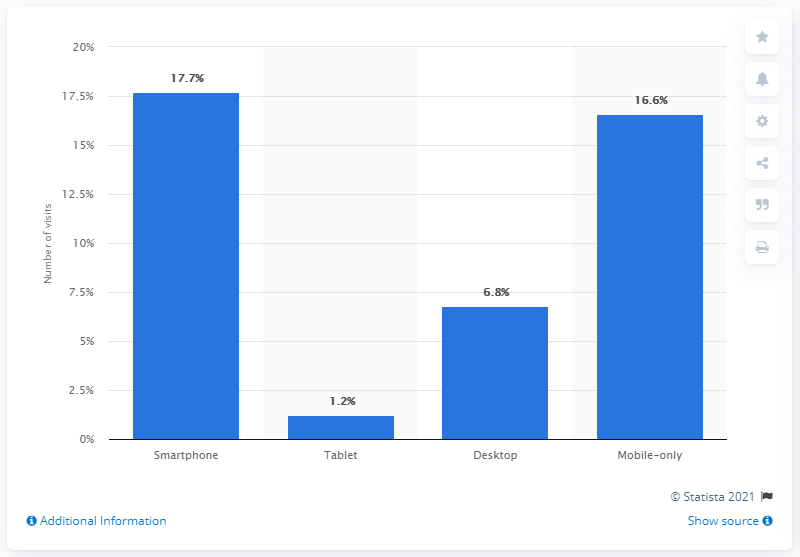Point out several critical features in this image. In April 2017, 17.7% of all adults in the United States had used Uber through their smartphones. There are 6.8 desktop computers that use Uber. 